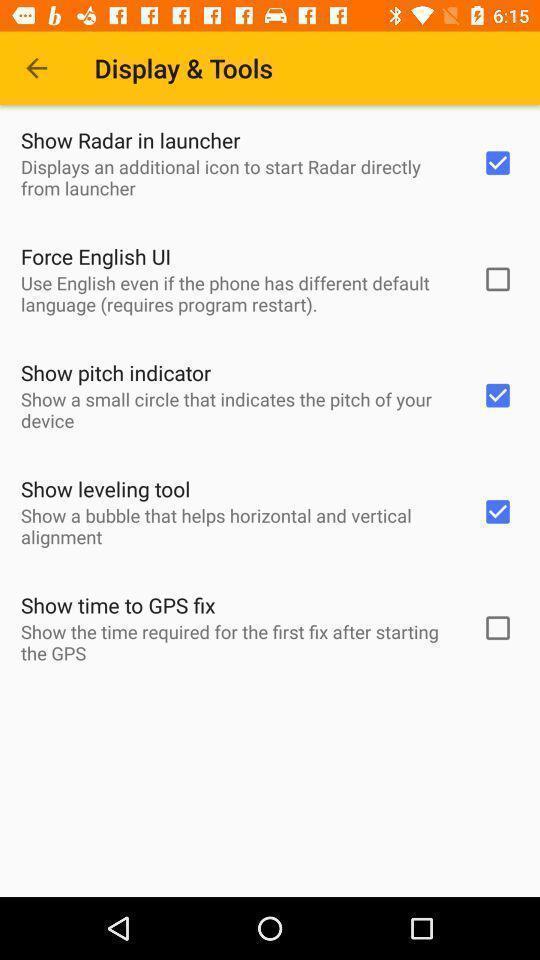Summarize the main components in this picture. Screen shows different checkboxes. 